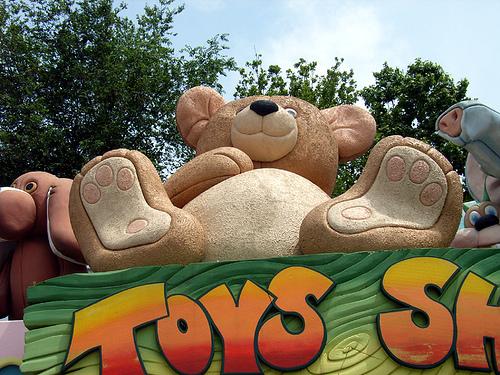What type of animal is the statue based on?
Write a very short answer. Bear. How many letters are seen in the picture?
Write a very short answer. 6. What word is readable in the photo?
Concise answer only. Toys. 